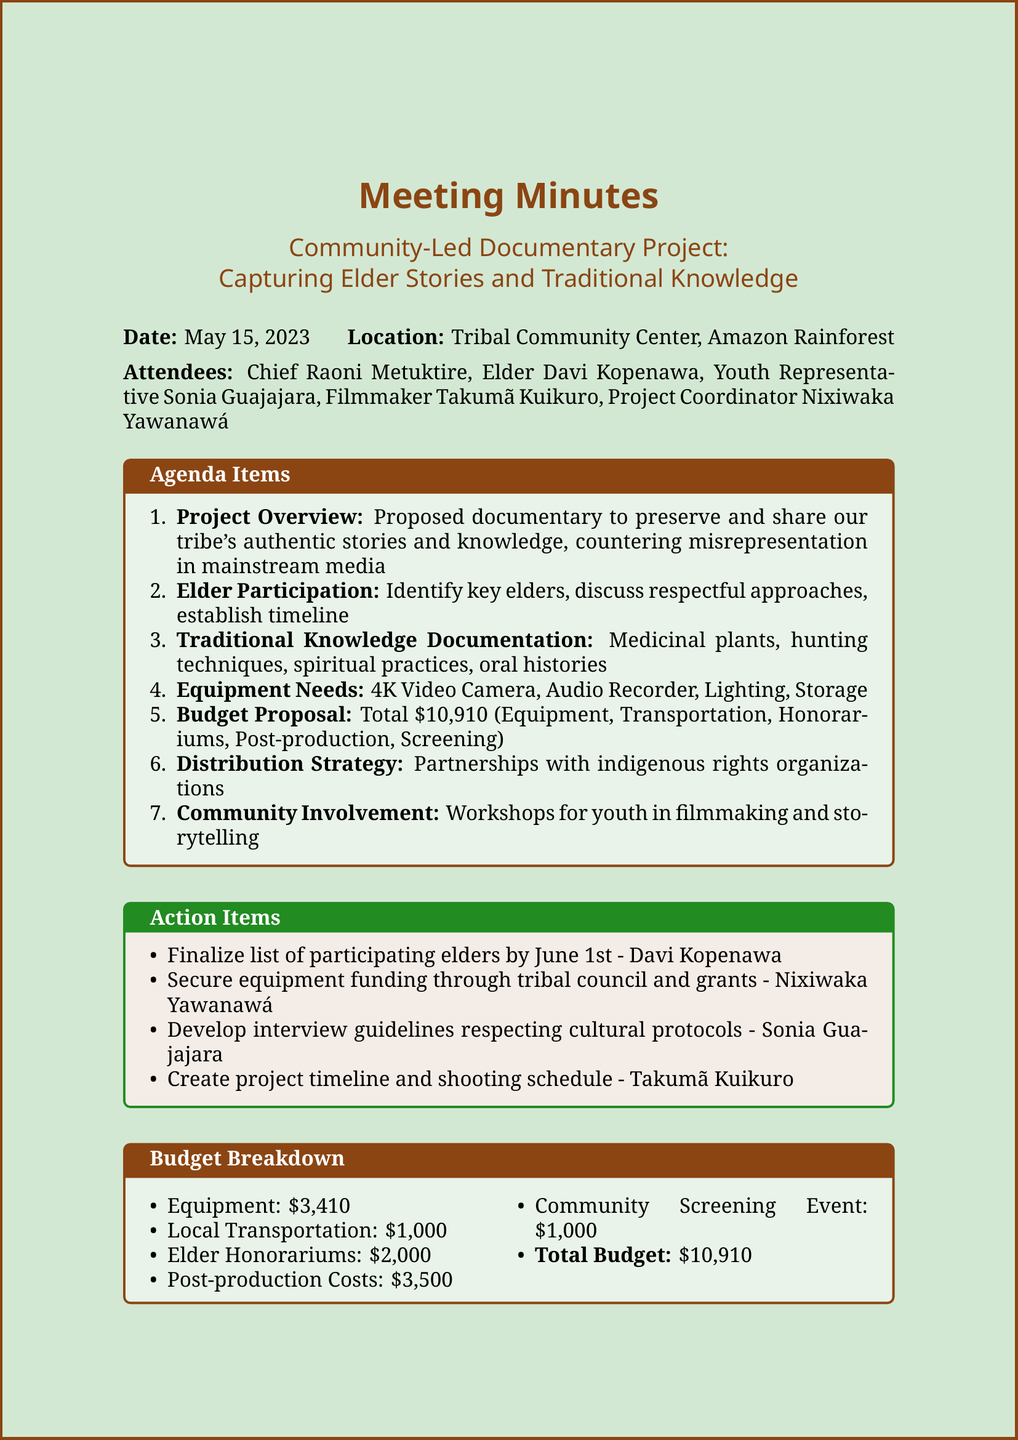what is the date of the meeting? The date of the meeting is specified at the top of the document under "Date."
Answer: May 15, 2023 who is the project coordinator? The project coordinator's name is listed in the "Attendees" section of the document.
Answer: Nixiwaka Yawanawá what is the total budget of the project? The total budget is listed in the "Budget Proposal" section.
Answer: $10,910 what equipment is needed for the documentary? The document lists specific equipment under "Equipment Needs."
Answer: 4K Video Camera, Audio Recorder, Lighting, Storage who is responsible for finalizing the list of participating elders? This responsibility is mentioned in the "Action Items" section.
Answer: Davi Kopenawa how much is allocated for Elder Honorariums? The amount for Elder Honorariums is stated in the "Budget Proposal" section.
Answer: $2,000 what is the purpose of the documentary? The purpose is outlined in the "Project Overview" section.
Answer: Preserve and share our tribe's authentic stories and knowledge where will the community screening event take place? The location is not explicitly stated in the document, but it is implied to be within the community.
Answer: Community Center what aspect of culture is being documented according to the agenda? The agenda specifies various aspects to be documented under "Traditional Knowledge Documentation."
Answer: Medicinal plants, hunting techniques, spiritual practices, and oral histories 